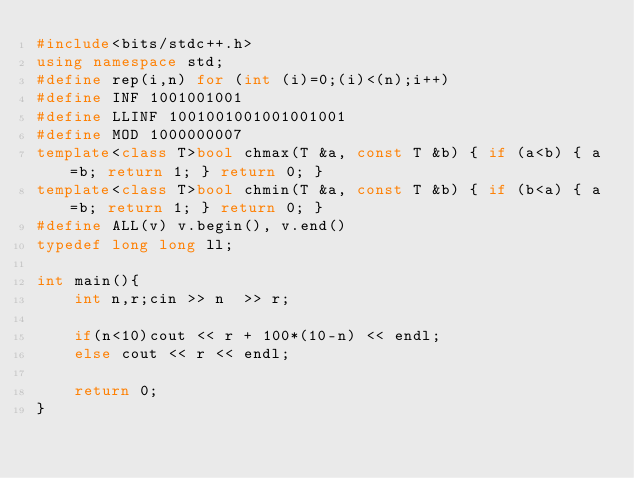<code> <loc_0><loc_0><loc_500><loc_500><_C++_>#include<bits/stdc++.h>
using namespace std;
#define rep(i,n) for (int (i)=0;(i)<(n);i++)
#define INF 1001001001
#define LLINF 1001001001001001001
#define MOD 1000000007
template<class T>bool chmax(T &a, const T &b) { if (a<b) { a=b; return 1; } return 0; }
template<class T>bool chmin(T &a, const T &b) { if (b<a) { a=b; return 1; } return 0; }
#define ALL(v) v.begin(), v.end()
typedef long long ll;

int main(){
    int n,r;cin >> n  >> r;

    if(n<10)cout << r + 100*(10-n) << endl;
    else cout << r << endl;

    return 0;
}</code> 